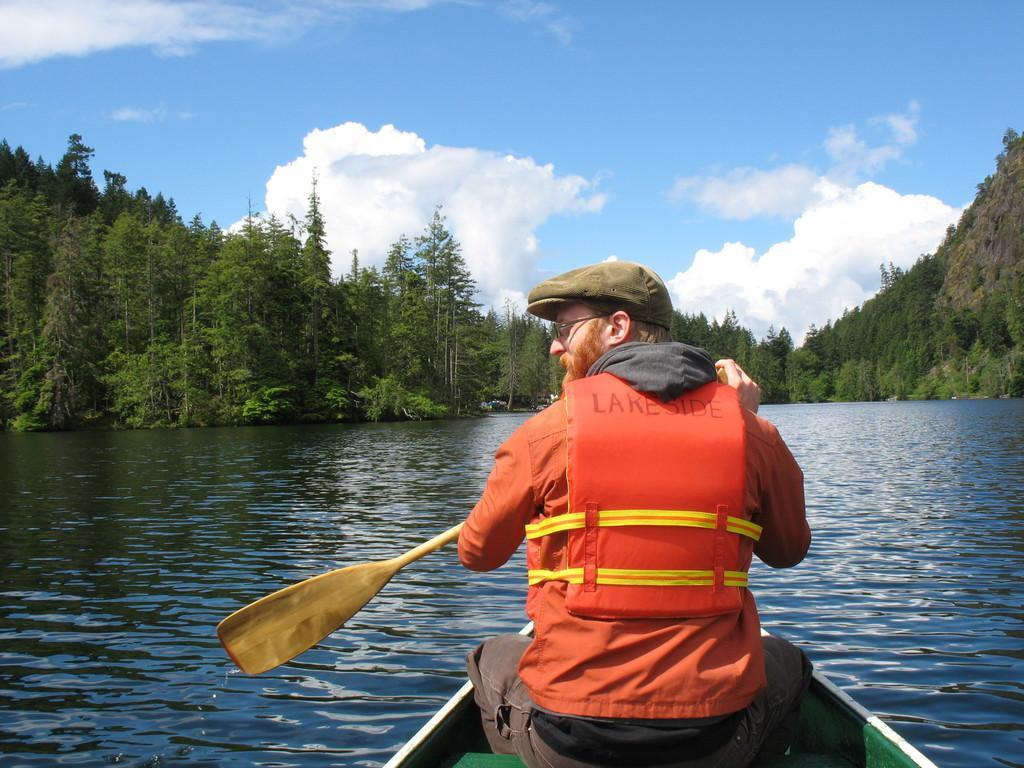Describe this image in one or two sentences. On the right side, there is a person in an orange color jacket, wearing a cap, holding a wooden object and sitting in a boat, which is on the water. In the background, there are trees on the mountains and there are clouds in the sky. 